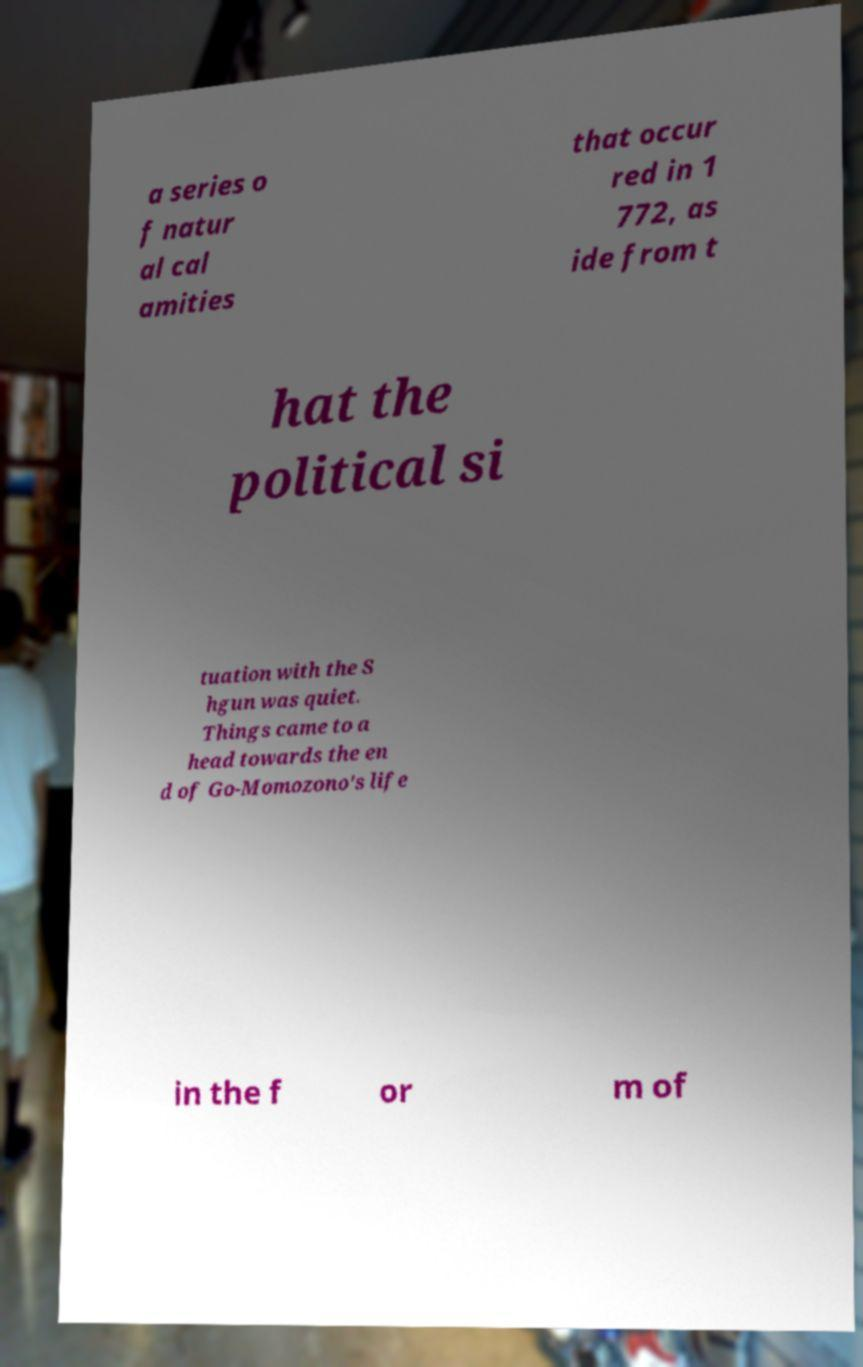What messages or text are displayed in this image? I need them in a readable, typed format. a series o f natur al cal amities that occur red in 1 772, as ide from t hat the political si tuation with the S hgun was quiet. Things came to a head towards the en d of Go-Momozono's life in the f or m of 